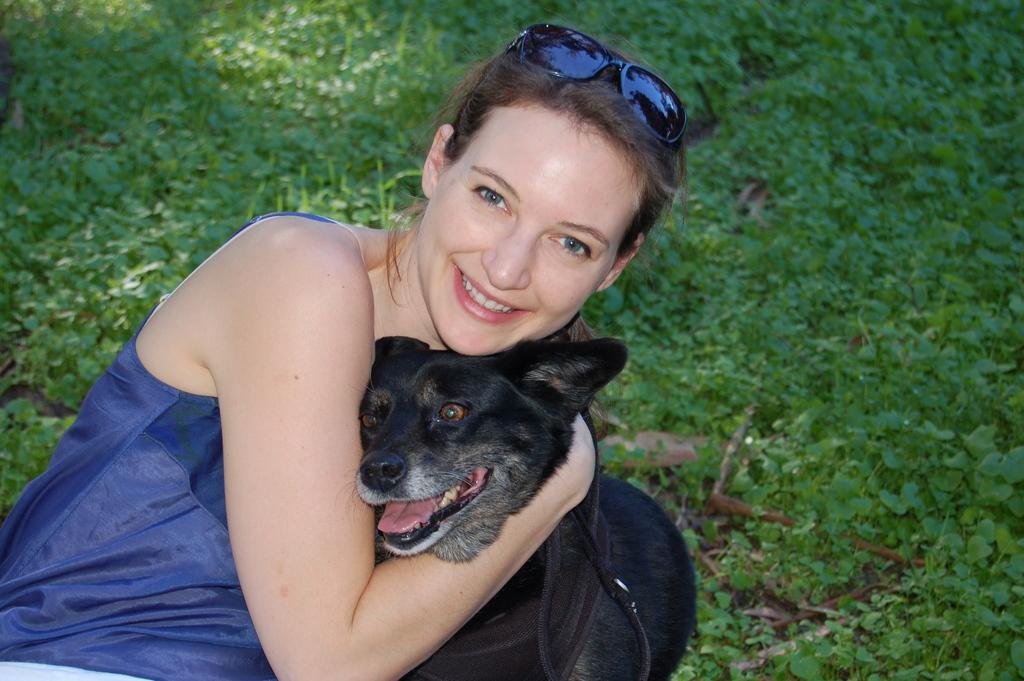Who is present in the image? There is a lady in the image. What is the lady wearing on her head? The lady is wearing spectacles on her head. What is the lady holding in the image? The lady is holding a black dog. Where was the image taken? The image was taken in a lawn. What type of sofa can be seen in the image? There is no sofa present in the image. 